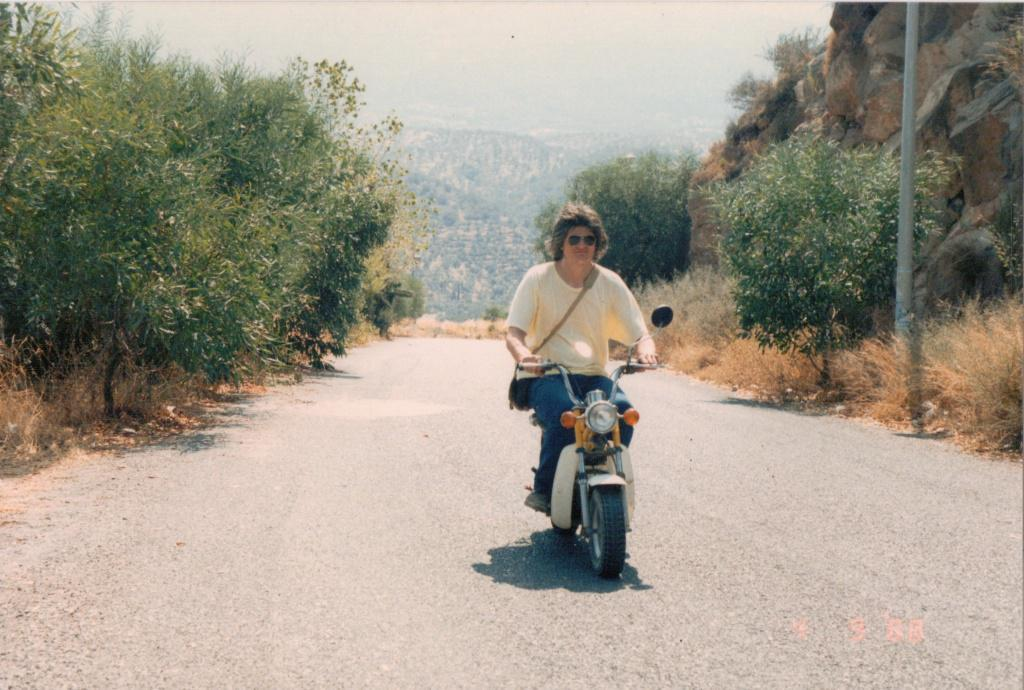What is the person in the image doing? There is a person riding a motorcycle in the image. Where is the motorcycle located in relation to the mountains? The motorcycle is between two mountains in the image. What type of natural environment is visible in the image? Trees are present in the image, indicating a forested area. What type of roll is being prepared by the person on the motorcycle? There is no roll being prepared in the image; the person is riding a motorcycle between two mountains. 